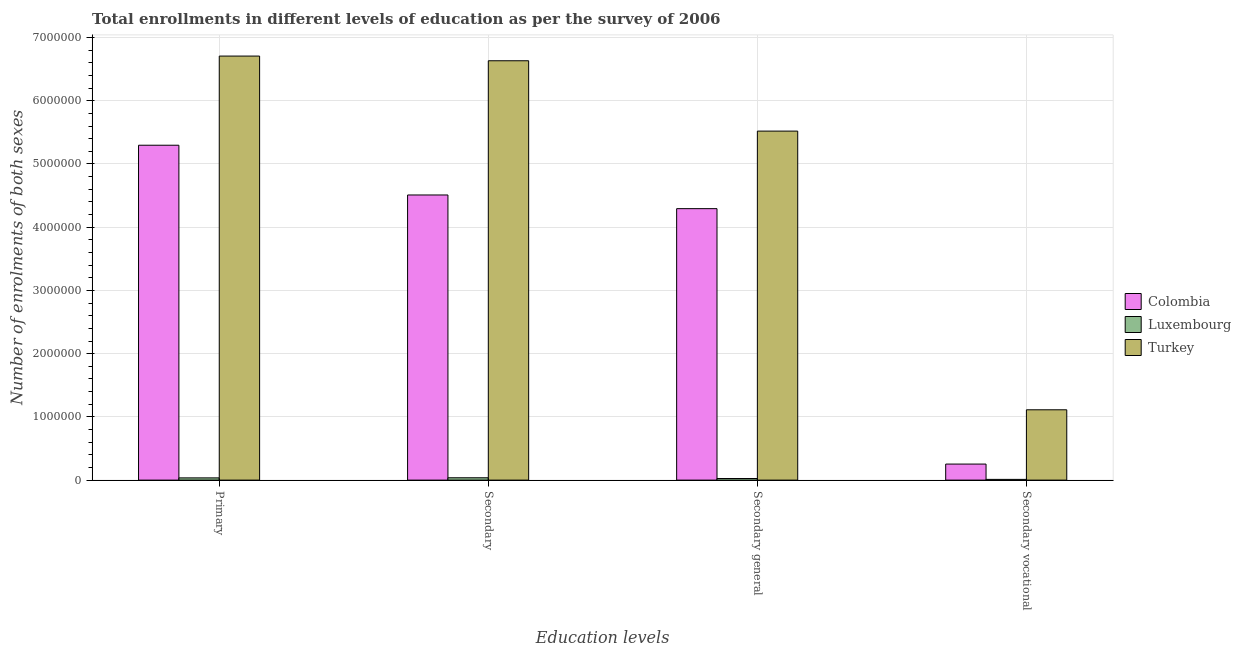How many groups of bars are there?
Ensure brevity in your answer.  4. Are the number of bars per tick equal to the number of legend labels?
Your response must be concise. Yes. Are the number of bars on each tick of the X-axis equal?
Offer a terse response. Yes. How many bars are there on the 2nd tick from the right?
Keep it short and to the point. 3. What is the label of the 3rd group of bars from the left?
Your response must be concise. Secondary general. What is the number of enrolments in primary education in Luxembourg?
Offer a terse response. 3.54e+04. Across all countries, what is the maximum number of enrolments in primary education?
Provide a succinct answer. 6.71e+06. Across all countries, what is the minimum number of enrolments in secondary general education?
Make the answer very short. 2.55e+04. In which country was the number of enrolments in secondary general education maximum?
Provide a succinct answer. Turkey. In which country was the number of enrolments in secondary education minimum?
Your answer should be compact. Luxembourg. What is the total number of enrolments in primary education in the graph?
Make the answer very short. 1.20e+07. What is the difference between the number of enrolments in secondary education in Luxembourg and that in Colombia?
Provide a short and direct response. -4.47e+06. What is the difference between the number of enrolments in secondary education in Colombia and the number of enrolments in primary education in Turkey?
Ensure brevity in your answer.  -2.20e+06. What is the average number of enrolments in primary education per country?
Provide a succinct answer. 4.01e+06. What is the difference between the number of enrolments in secondary general education and number of enrolments in secondary education in Colombia?
Your answer should be compact. -2.16e+05. In how many countries, is the number of enrolments in primary education greater than 3400000 ?
Keep it short and to the point. 2. What is the ratio of the number of enrolments in secondary vocational education in Colombia to that in Turkey?
Your answer should be very brief. 0.23. Is the number of enrolments in secondary general education in Turkey less than that in Luxembourg?
Your answer should be very brief. No. Is the difference between the number of enrolments in secondary vocational education in Colombia and Turkey greater than the difference between the number of enrolments in primary education in Colombia and Turkey?
Keep it short and to the point. Yes. What is the difference between the highest and the second highest number of enrolments in secondary general education?
Offer a terse response. 1.23e+06. What is the difference between the highest and the lowest number of enrolments in secondary vocational education?
Make the answer very short. 1.10e+06. What does the 2nd bar from the left in Secondary general represents?
Your answer should be very brief. Luxembourg. Is it the case that in every country, the sum of the number of enrolments in primary education and number of enrolments in secondary education is greater than the number of enrolments in secondary general education?
Make the answer very short. Yes. How many bars are there?
Provide a short and direct response. 12. What is the difference between two consecutive major ticks on the Y-axis?
Provide a short and direct response. 1.00e+06. Where does the legend appear in the graph?
Your response must be concise. Center right. How are the legend labels stacked?
Give a very brief answer. Vertical. What is the title of the graph?
Make the answer very short. Total enrollments in different levels of education as per the survey of 2006. What is the label or title of the X-axis?
Your answer should be very brief. Education levels. What is the label or title of the Y-axis?
Offer a very short reply. Number of enrolments of both sexes. What is the Number of enrolments of both sexes of Colombia in Primary?
Your answer should be very brief. 5.30e+06. What is the Number of enrolments of both sexes in Luxembourg in Primary?
Keep it short and to the point. 3.54e+04. What is the Number of enrolments of both sexes of Turkey in Primary?
Give a very brief answer. 6.71e+06. What is the Number of enrolments of both sexes of Colombia in Secondary?
Your answer should be very brief. 4.51e+06. What is the Number of enrolments of both sexes in Luxembourg in Secondary?
Keep it short and to the point. 3.70e+04. What is the Number of enrolments of both sexes in Turkey in Secondary?
Provide a succinct answer. 6.63e+06. What is the Number of enrolments of both sexes of Colombia in Secondary general?
Your answer should be very brief. 4.29e+06. What is the Number of enrolments of both sexes of Luxembourg in Secondary general?
Provide a short and direct response. 2.55e+04. What is the Number of enrolments of both sexes of Turkey in Secondary general?
Your response must be concise. 5.52e+06. What is the Number of enrolments of both sexes of Colombia in Secondary vocational?
Ensure brevity in your answer.  2.54e+05. What is the Number of enrolments of both sexes of Luxembourg in Secondary vocational?
Your answer should be very brief. 1.16e+04. What is the Number of enrolments of both sexes in Turkey in Secondary vocational?
Make the answer very short. 1.11e+06. Across all Education levels, what is the maximum Number of enrolments of both sexes of Colombia?
Make the answer very short. 5.30e+06. Across all Education levels, what is the maximum Number of enrolments of both sexes of Luxembourg?
Your response must be concise. 3.70e+04. Across all Education levels, what is the maximum Number of enrolments of both sexes in Turkey?
Provide a short and direct response. 6.71e+06. Across all Education levels, what is the minimum Number of enrolments of both sexes in Colombia?
Your answer should be very brief. 2.54e+05. Across all Education levels, what is the minimum Number of enrolments of both sexes of Luxembourg?
Offer a very short reply. 1.16e+04. Across all Education levels, what is the minimum Number of enrolments of both sexes in Turkey?
Your response must be concise. 1.11e+06. What is the total Number of enrolments of both sexes of Colombia in the graph?
Provide a succinct answer. 1.44e+07. What is the total Number of enrolments of both sexes in Luxembourg in the graph?
Provide a short and direct response. 1.09e+05. What is the total Number of enrolments of both sexes of Turkey in the graph?
Ensure brevity in your answer.  2.00e+07. What is the difference between the Number of enrolments of both sexes of Colombia in Primary and that in Secondary?
Provide a short and direct response. 7.87e+05. What is the difference between the Number of enrolments of both sexes in Luxembourg in Primary and that in Secondary?
Make the answer very short. -1578. What is the difference between the Number of enrolments of both sexes of Turkey in Primary and that in Secondary?
Provide a succinct answer. 7.41e+04. What is the difference between the Number of enrolments of both sexes in Colombia in Primary and that in Secondary general?
Give a very brief answer. 1.00e+06. What is the difference between the Number of enrolments of both sexes in Luxembourg in Primary and that in Secondary general?
Your response must be concise. 9975. What is the difference between the Number of enrolments of both sexes in Turkey in Primary and that in Secondary general?
Keep it short and to the point. 1.19e+06. What is the difference between the Number of enrolments of both sexes of Colombia in Primary and that in Secondary vocational?
Ensure brevity in your answer.  5.04e+06. What is the difference between the Number of enrolments of both sexes of Luxembourg in Primary and that in Secondary vocational?
Make the answer very short. 2.39e+04. What is the difference between the Number of enrolments of both sexes in Turkey in Primary and that in Secondary vocational?
Give a very brief answer. 5.59e+06. What is the difference between the Number of enrolments of both sexes of Colombia in Secondary and that in Secondary general?
Give a very brief answer. 2.16e+05. What is the difference between the Number of enrolments of both sexes of Luxembourg in Secondary and that in Secondary general?
Keep it short and to the point. 1.16e+04. What is the difference between the Number of enrolments of both sexes of Turkey in Secondary and that in Secondary general?
Offer a very short reply. 1.11e+06. What is the difference between the Number of enrolments of both sexes of Colombia in Secondary and that in Secondary vocational?
Your answer should be compact. 4.26e+06. What is the difference between the Number of enrolments of both sexes in Luxembourg in Secondary and that in Secondary vocational?
Offer a very short reply. 2.55e+04. What is the difference between the Number of enrolments of both sexes in Turkey in Secondary and that in Secondary vocational?
Provide a succinct answer. 5.52e+06. What is the difference between the Number of enrolments of both sexes in Colombia in Secondary general and that in Secondary vocational?
Offer a terse response. 4.04e+06. What is the difference between the Number of enrolments of both sexes in Luxembourg in Secondary general and that in Secondary vocational?
Ensure brevity in your answer.  1.39e+04. What is the difference between the Number of enrolments of both sexes of Turkey in Secondary general and that in Secondary vocational?
Ensure brevity in your answer.  4.41e+06. What is the difference between the Number of enrolments of both sexes in Colombia in Primary and the Number of enrolments of both sexes in Luxembourg in Secondary?
Give a very brief answer. 5.26e+06. What is the difference between the Number of enrolments of both sexes in Colombia in Primary and the Number of enrolments of both sexes in Turkey in Secondary?
Offer a terse response. -1.34e+06. What is the difference between the Number of enrolments of both sexes of Luxembourg in Primary and the Number of enrolments of both sexes of Turkey in Secondary?
Keep it short and to the point. -6.60e+06. What is the difference between the Number of enrolments of both sexes of Colombia in Primary and the Number of enrolments of both sexes of Luxembourg in Secondary general?
Give a very brief answer. 5.27e+06. What is the difference between the Number of enrolments of both sexes of Colombia in Primary and the Number of enrolments of both sexes of Turkey in Secondary general?
Ensure brevity in your answer.  -2.23e+05. What is the difference between the Number of enrolments of both sexes in Luxembourg in Primary and the Number of enrolments of both sexes in Turkey in Secondary general?
Provide a short and direct response. -5.48e+06. What is the difference between the Number of enrolments of both sexes of Colombia in Primary and the Number of enrolments of both sexes of Luxembourg in Secondary vocational?
Keep it short and to the point. 5.28e+06. What is the difference between the Number of enrolments of both sexes of Colombia in Primary and the Number of enrolments of both sexes of Turkey in Secondary vocational?
Your answer should be compact. 4.18e+06. What is the difference between the Number of enrolments of both sexes of Luxembourg in Primary and the Number of enrolments of both sexes of Turkey in Secondary vocational?
Your answer should be compact. -1.08e+06. What is the difference between the Number of enrolments of both sexes in Colombia in Secondary and the Number of enrolments of both sexes in Luxembourg in Secondary general?
Your answer should be compact. 4.48e+06. What is the difference between the Number of enrolments of both sexes of Colombia in Secondary and the Number of enrolments of both sexes of Turkey in Secondary general?
Your response must be concise. -1.01e+06. What is the difference between the Number of enrolments of both sexes of Luxembourg in Secondary and the Number of enrolments of both sexes of Turkey in Secondary general?
Give a very brief answer. -5.48e+06. What is the difference between the Number of enrolments of both sexes in Colombia in Secondary and the Number of enrolments of both sexes in Luxembourg in Secondary vocational?
Your answer should be compact. 4.50e+06. What is the difference between the Number of enrolments of both sexes in Colombia in Secondary and the Number of enrolments of both sexes in Turkey in Secondary vocational?
Provide a short and direct response. 3.40e+06. What is the difference between the Number of enrolments of both sexes in Luxembourg in Secondary and the Number of enrolments of both sexes in Turkey in Secondary vocational?
Your response must be concise. -1.08e+06. What is the difference between the Number of enrolments of both sexes of Colombia in Secondary general and the Number of enrolments of both sexes of Luxembourg in Secondary vocational?
Your answer should be compact. 4.28e+06. What is the difference between the Number of enrolments of both sexes of Colombia in Secondary general and the Number of enrolments of both sexes of Turkey in Secondary vocational?
Make the answer very short. 3.18e+06. What is the difference between the Number of enrolments of both sexes in Luxembourg in Secondary general and the Number of enrolments of both sexes in Turkey in Secondary vocational?
Offer a very short reply. -1.09e+06. What is the average Number of enrolments of both sexes in Colombia per Education levels?
Make the answer very short. 3.59e+06. What is the average Number of enrolments of both sexes of Luxembourg per Education levels?
Give a very brief answer. 2.74e+04. What is the average Number of enrolments of both sexes of Turkey per Education levels?
Give a very brief answer. 4.99e+06. What is the difference between the Number of enrolments of both sexes in Colombia and Number of enrolments of both sexes in Luxembourg in Primary?
Your answer should be very brief. 5.26e+06. What is the difference between the Number of enrolments of both sexes in Colombia and Number of enrolments of both sexes in Turkey in Primary?
Ensure brevity in your answer.  -1.41e+06. What is the difference between the Number of enrolments of both sexes of Luxembourg and Number of enrolments of both sexes of Turkey in Primary?
Offer a very short reply. -6.67e+06. What is the difference between the Number of enrolments of both sexes of Colombia and Number of enrolments of both sexes of Luxembourg in Secondary?
Your answer should be compact. 4.47e+06. What is the difference between the Number of enrolments of both sexes of Colombia and Number of enrolments of both sexes of Turkey in Secondary?
Your answer should be compact. -2.12e+06. What is the difference between the Number of enrolments of both sexes in Luxembourg and Number of enrolments of both sexes in Turkey in Secondary?
Make the answer very short. -6.59e+06. What is the difference between the Number of enrolments of both sexes of Colombia and Number of enrolments of both sexes of Luxembourg in Secondary general?
Keep it short and to the point. 4.27e+06. What is the difference between the Number of enrolments of both sexes in Colombia and Number of enrolments of both sexes in Turkey in Secondary general?
Your response must be concise. -1.23e+06. What is the difference between the Number of enrolments of both sexes in Luxembourg and Number of enrolments of both sexes in Turkey in Secondary general?
Your answer should be compact. -5.49e+06. What is the difference between the Number of enrolments of both sexes in Colombia and Number of enrolments of both sexes in Luxembourg in Secondary vocational?
Ensure brevity in your answer.  2.42e+05. What is the difference between the Number of enrolments of both sexes in Colombia and Number of enrolments of both sexes in Turkey in Secondary vocational?
Your answer should be very brief. -8.58e+05. What is the difference between the Number of enrolments of both sexes of Luxembourg and Number of enrolments of both sexes of Turkey in Secondary vocational?
Ensure brevity in your answer.  -1.10e+06. What is the ratio of the Number of enrolments of both sexes of Colombia in Primary to that in Secondary?
Provide a succinct answer. 1.17. What is the ratio of the Number of enrolments of both sexes in Luxembourg in Primary to that in Secondary?
Ensure brevity in your answer.  0.96. What is the ratio of the Number of enrolments of both sexes of Turkey in Primary to that in Secondary?
Provide a short and direct response. 1.01. What is the ratio of the Number of enrolments of both sexes of Colombia in Primary to that in Secondary general?
Offer a very short reply. 1.23. What is the ratio of the Number of enrolments of both sexes of Luxembourg in Primary to that in Secondary general?
Give a very brief answer. 1.39. What is the ratio of the Number of enrolments of both sexes of Turkey in Primary to that in Secondary general?
Your response must be concise. 1.21. What is the ratio of the Number of enrolments of both sexes of Colombia in Primary to that in Secondary vocational?
Give a very brief answer. 20.86. What is the ratio of the Number of enrolments of both sexes in Luxembourg in Primary to that in Secondary vocational?
Offer a very short reply. 3.07. What is the ratio of the Number of enrolments of both sexes of Turkey in Primary to that in Secondary vocational?
Make the answer very short. 6.03. What is the ratio of the Number of enrolments of both sexes of Colombia in Secondary to that in Secondary general?
Keep it short and to the point. 1.05. What is the ratio of the Number of enrolments of both sexes in Luxembourg in Secondary to that in Secondary general?
Keep it short and to the point. 1.45. What is the ratio of the Number of enrolments of both sexes of Turkey in Secondary to that in Secondary general?
Give a very brief answer. 1.2. What is the ratio of the Number of enrolments of both sexes in Colombia in Secondary to that in Secondary vocational?
Make the answer very short. 17.76. What is the ratio of the Number of enrolments of both sexes of Luxembourg in Secondary to that in Secondary vocational?
Give a very brief answer. 3.2. What is the ratio of the Number of enrolments of both sexes in Turkey in Secondary to that in Secondary vocational?
Ensure brevity in your answer.  5.96. What is the ratio of the Number of enrolments of both sexes of Colombia in Secondary general to that in Secondary vocational?
Keep it short and to the point. 16.91. What is the ratio of the Number of enrolments of both sexes of Luxembourg in Secondary general to that in Secondary vocational?
Give a very brief answer. 2.2. What is the ratio of the Number of enrolments of both sexes in Turkey in Secondary general to that in Secondary vocational?
Your answer should be compact. 4.96. What is the difference between the highest and the second highest Number of enrolments of both sexes of Colombia?
Offer a very short reply. 7.87e+05. What is the difference between the highest and the second highest Number of enrolments of both sexes in Luxembourg?
Give a very brief answer. 1578. What is the difference between the highest and the second highest Number of enrolments of both sexes in Turkey?
Give a very brief answer. 7.41e+04. What is the difference between the highest and the lowest Number of enrolments of both sexes of Colombia?
Make the answer very short. 5.04e+06. What is the difference between the highest and the lowest Number of enrolments of both sexes in Luxembourg?
Ensure brevity in your answer.  2.55e+04. What is the difference between the highest and the lowest Number of enrolments of both sexes of Turkey?
Give a very brief answer. 5.59e+06. 